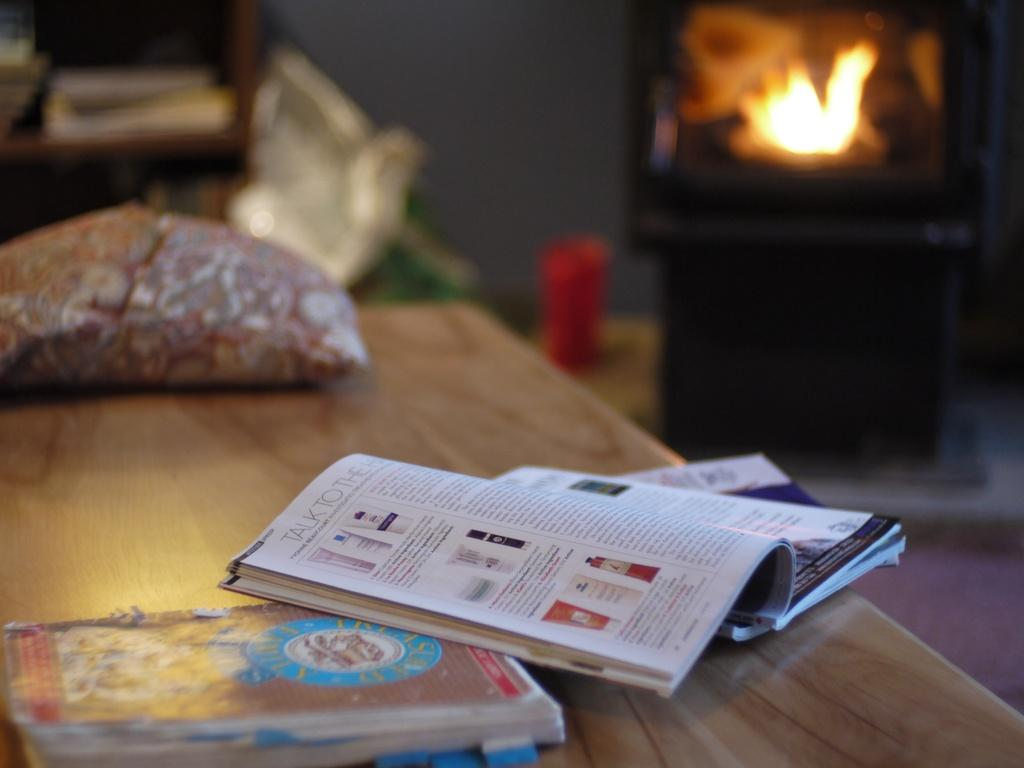What objects are on the table in the image? There is a group of books on the table. Can you describe the state of one of the books? One of the books is kept open. How does the tongue interact with the books in the image? There is no mention of a tongue interacting with the books in the image; it only shows a group of books on the table. 